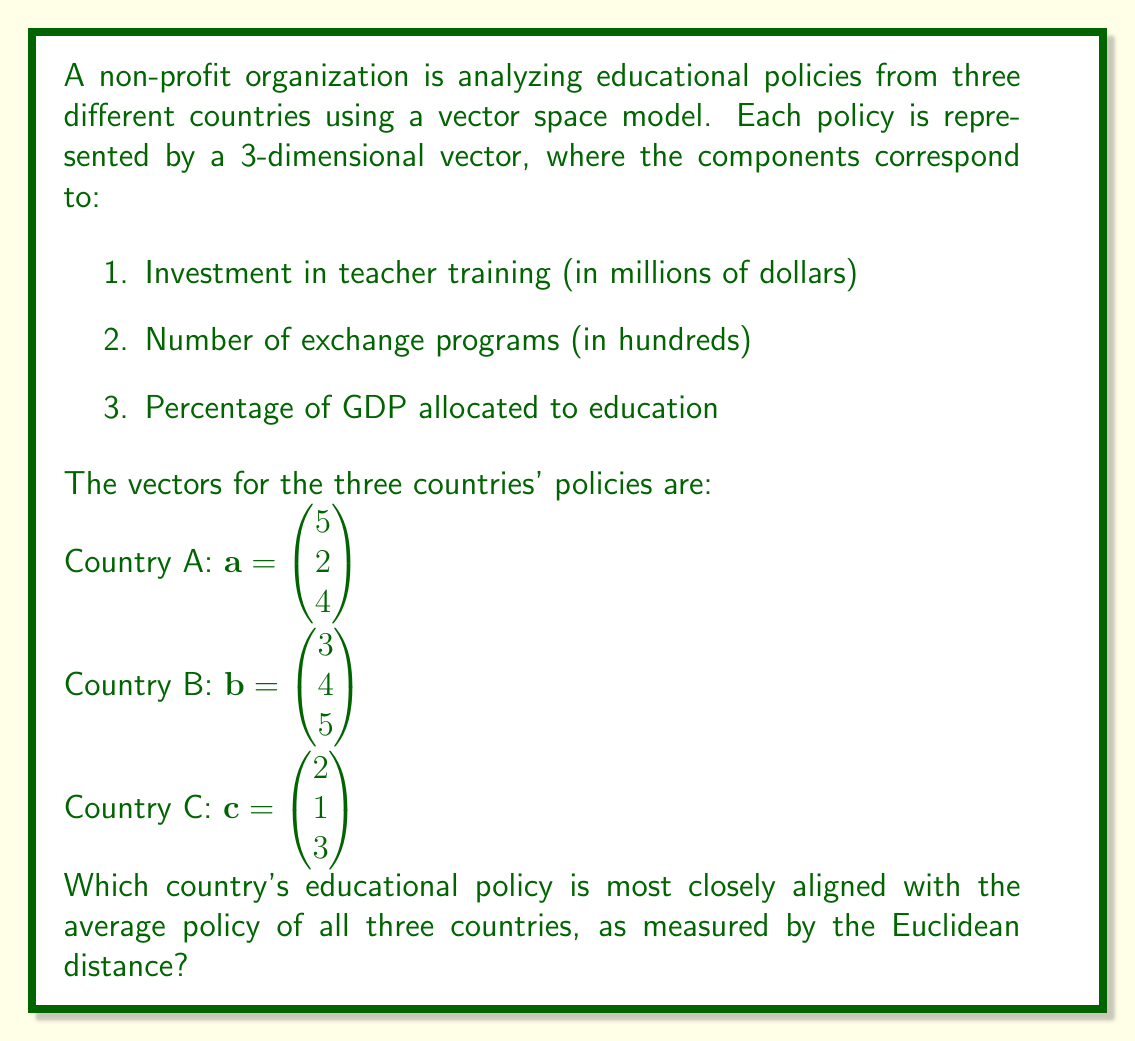Can you answer this question? To solve this problem, we'll follow these steps:

1. Calculate the average policy vector.
2. Calculate the Euclidean distance between each country's policy vector and the average vector.
3. Compare the distances to find the smallest one.

Step 1: Calculate the average policy vector

The average vector $\mathbf{v}_{\text{avg}}$ is the sum of all vectors divided by the number of vectors:

$$\mathbf{v}_{\text{avg}} = \frac{\mathbf{a} + \mathbf{b} + \mathbf{c}}{3}$$

$$\mathbf{v}_{\text{avg}} = \frac{1}{3}\begin{pmatrix} 5+3+2 \\ 2+4+1 \\ 4+5+3 \end{pmatrix} = \begin{pmatrix} 10/3 \\ 7/3 \\ 4 \end{pmatrix}$$

Step 2: Calculate the Euclidean distance

The Euclidean distance between two vectors $\mathbf{u} = (u_1, u_2, u_3)$ and $\mathbf{v} = (v_1, v_2, v_3)$ is given by:

$$d(\mathbf{u}, \mathbf{v}) = \sqrt{(u_1 - v_1)^2 + (u_2 - v_2)^2 + (u_3 - v_3)^2}$$

For Country A:
$$d_A = \sqrt{(5 - 10/3)^2 + (2 - 7/3)^2 + (4 - 4)^2} \approx 1.89$$

For Country B:
$$d_B = \sqrt{(3 - 10/3)^2 + (4 - 7/3)^2 + (5 - 4)^2} \approx 1.70$$

For Country C:
$$d_C = \sqrt{(2 - 10/3)^2 + (1 - 7/3)^2 + (3 - 4)^2} \approx 2.05$$

Step 3: Compare the distances

The smallest distance is $d_B \approx 1.70$, corresponding to Country B.
Answer: Country B 